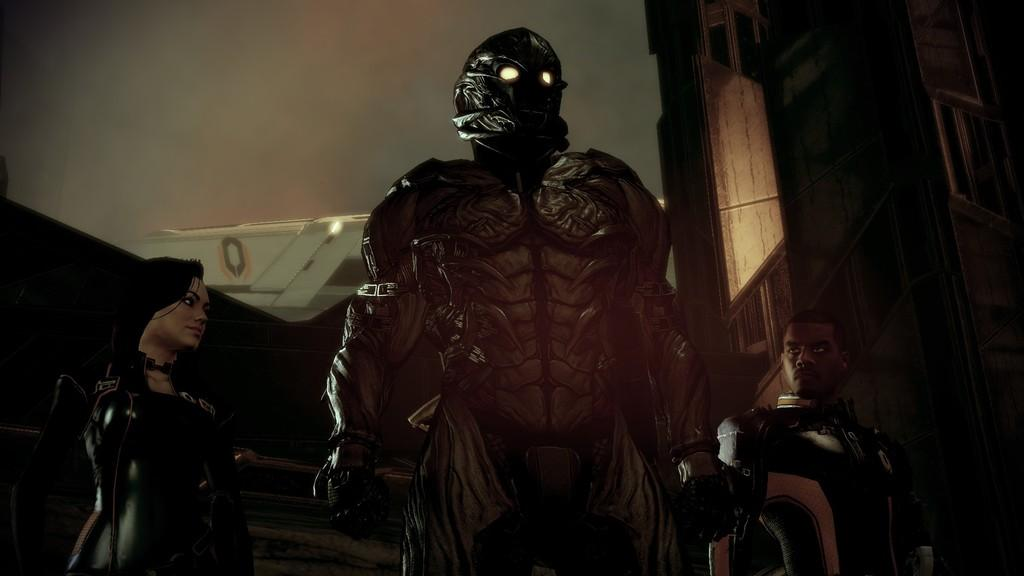How many people are in the image? There are two persons in the image. What are the persons wearing? The persons are wearing costumes. What are the persons doing in the image? The persons are standing. What other object can be seen in the image? There is a statue in the image. Can you tell me how many ducks are sitting on the boundary in the image? There are no ducks or boundaries present in the image. What type of cheese is being used to decorate the statue in the image? There is: There is no cheese present in the image. 